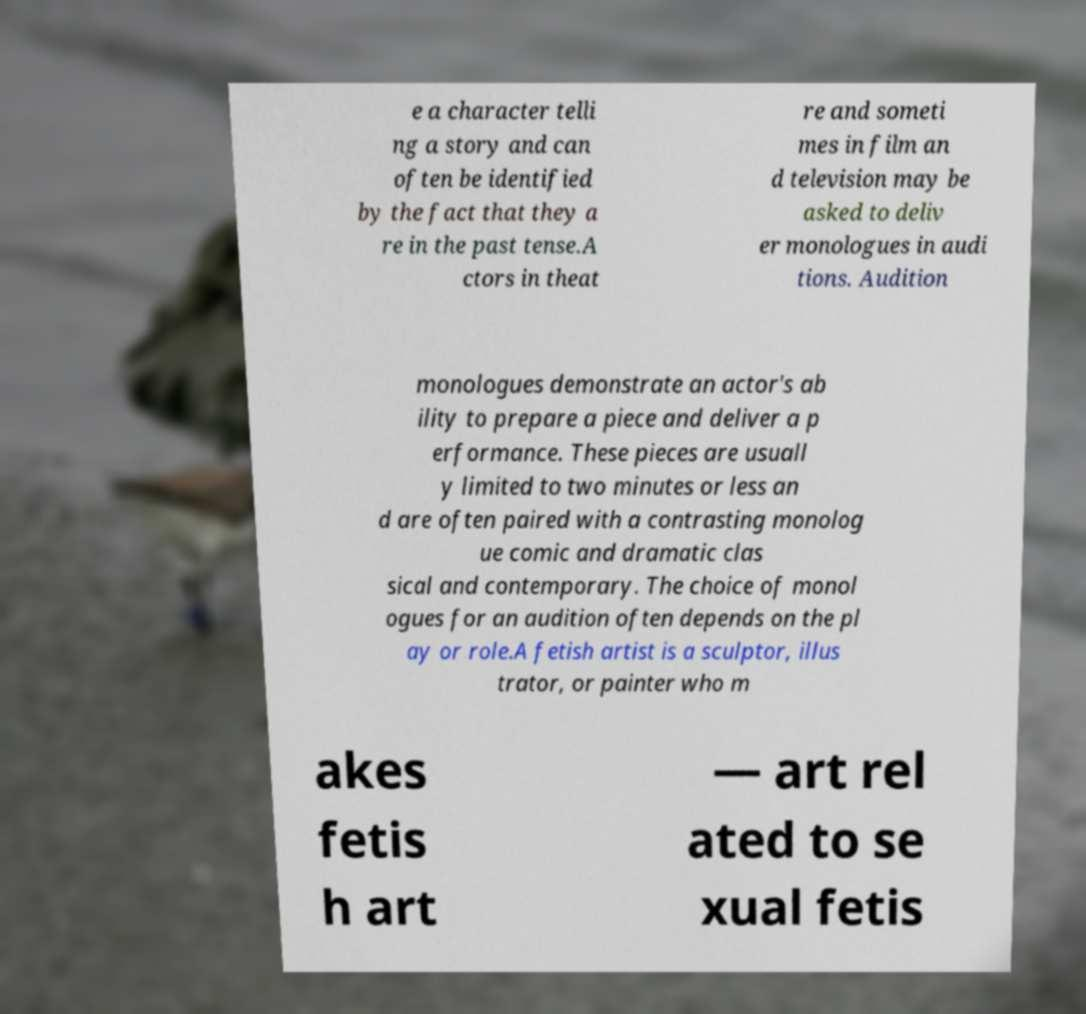There's text embedded in this image that I need extracted. Can you transcribe it verbatim? e a character telli ng a story and can often be identified by the fact that they a re in the past tense.A ctors in theat re and someti mes in film an d television may be asked to deliv er monologues in audi tions. Audition monologues demonstrate an actor's ab ility to prepare a piece and deliver a p erformance. These pieces are usuall y limited to two minutes or less an d are often paired with a contrasting monolog ue comic and dramatic clas sical and contemporary. The choice of monol ogues for an audition often depends on the pl ay or role.A fetish artist is a sculptor, illus trator, or painter who m akes fetis h art — art rel ated to se xual fetis 